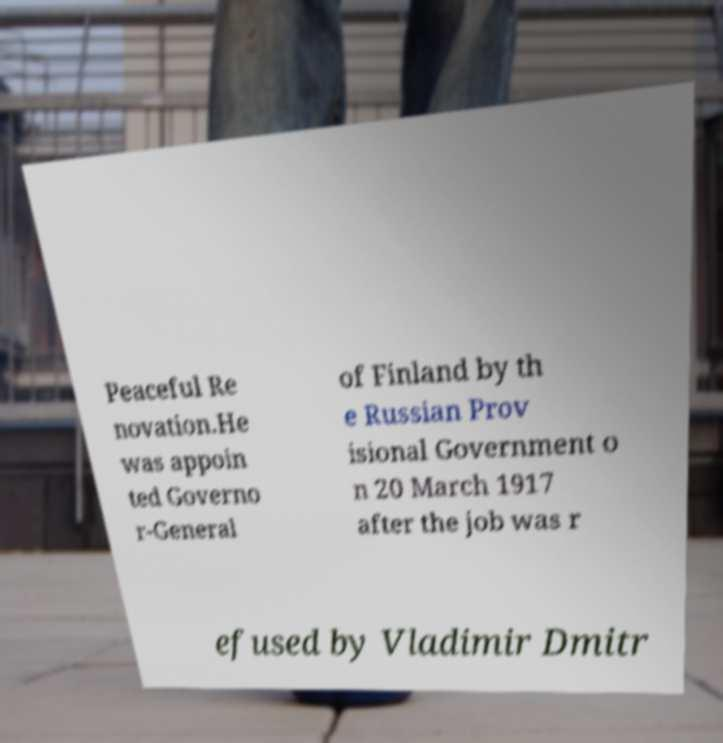For documentation purposes, I need the text within this image transcribed. Could you provide that? Peaceful Re novation.He was appoin ted Governo r-General of Finland by th e Russian Prov isional Government o n 20 March 1917 after the job was r efused by Vladimir Dmitr 